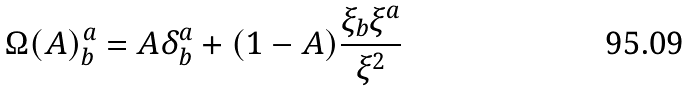<formula> <loc_0><loc_0><loc_500><loc_500>\Omega ( A ) _ { b } ^ { a } = A \delta _ { b } ^ { a } + ( 1 - A ) \frac { \xi _ { b } \xi ^ { a } } { \xi ^ { 2 } }</formula> 